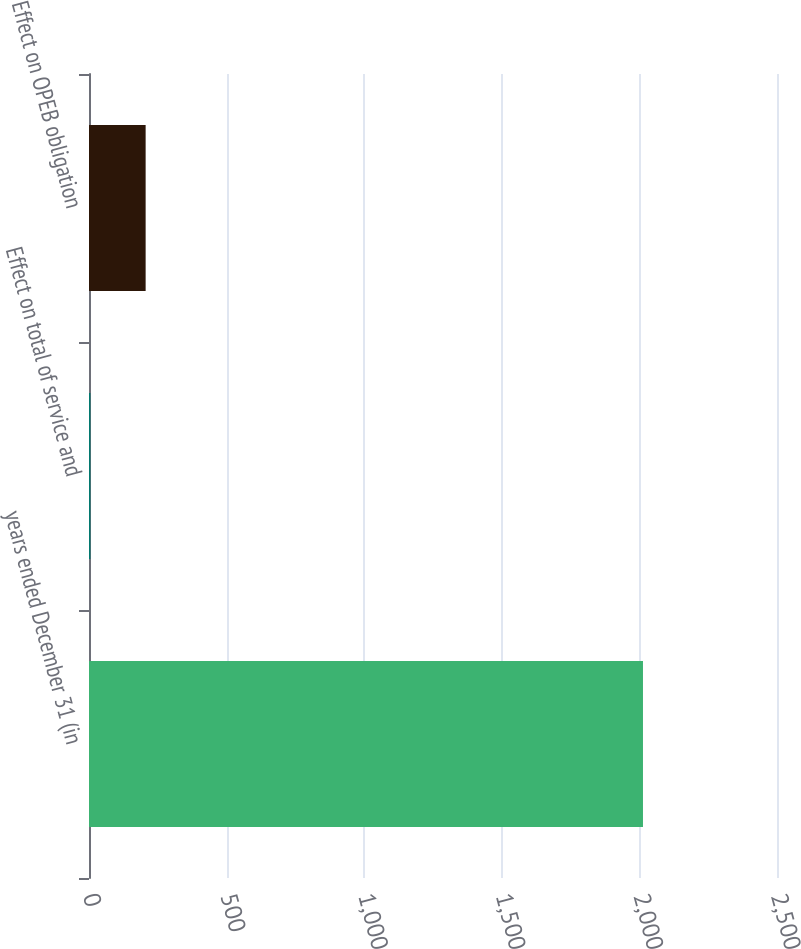Convert chart to OTSL. <chart><loc_0><loc_0><loc_500><loc_500><bar_chart><fcel>years ended December 31 (in<fcel>Effect on total of service and<fcel>Effect on OPEB obligation<nl><fcel>2013<fcel>5<fcel>205.8<nl></chart> 